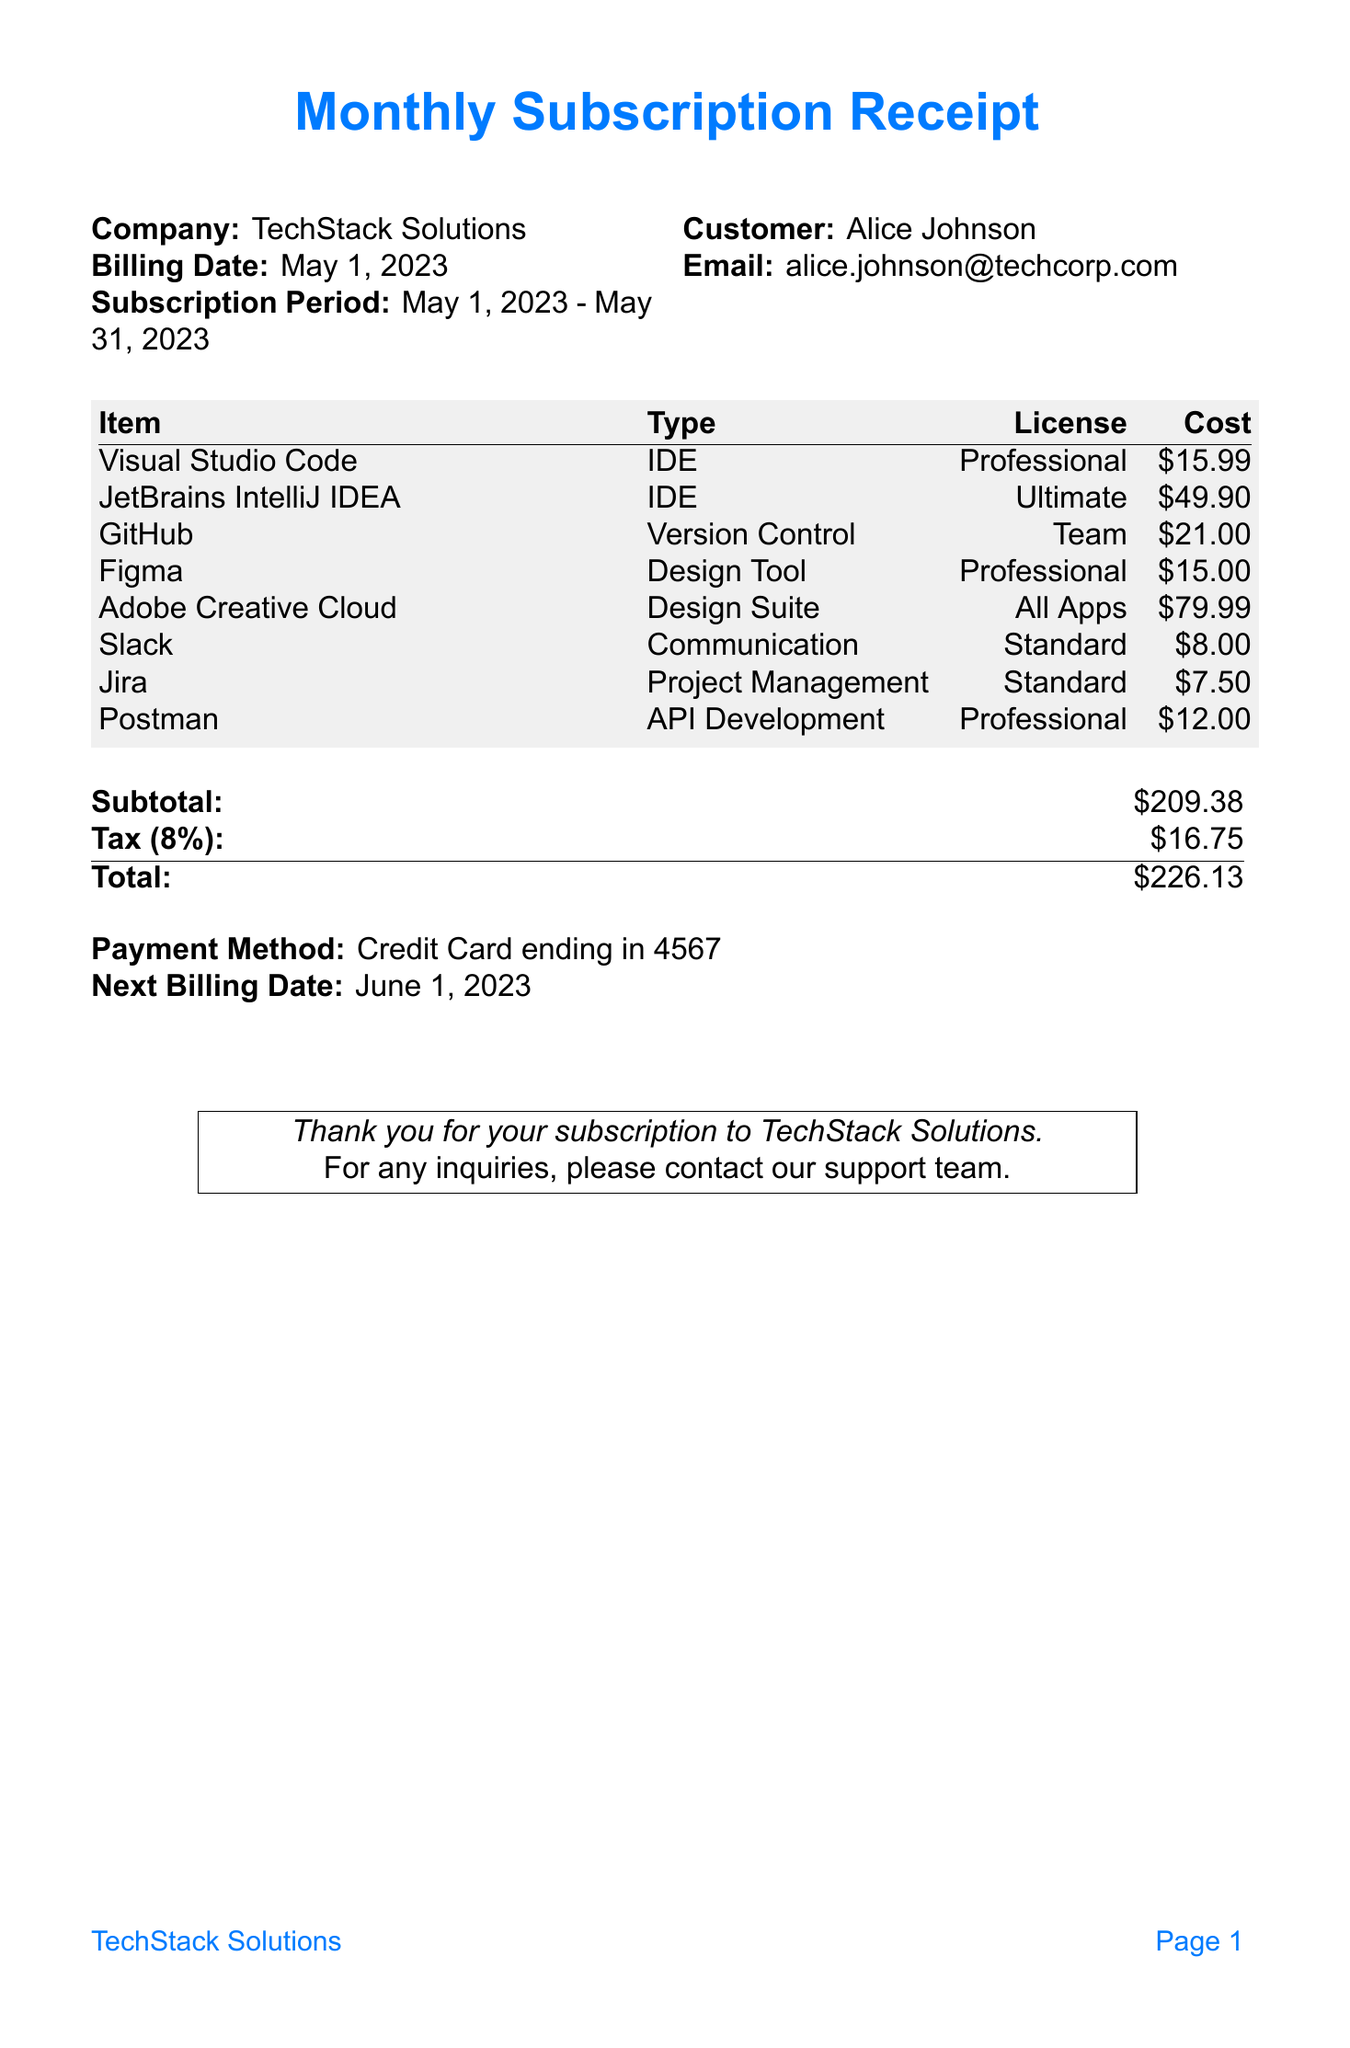what is the billing date? The billing date is specified in the document under the billing details.
Answer: May 1, 2023 who is the customer? The customer name is provided in the receipt, under the customer section.
Answer: Alice Johnson what is the total amount due? The total amount is calculated after subtotal and tax, provided at the end of the receipt.
Answer: 226.13 how many items are listed in the subscription? The number of subscription items can be counted from the itemized list provided.
Answer: 8 what is the license type for GitHub? The license type for GitHub can be found in the subscription items section.
Answer: Team what is the tax rate applied? The tax rate is displayed in the financial summary section of the document.
Answer: 8% what subscription tool has the highest cost? The tool with the highest cost is identified by comparing the costs listed in the document.
Answer: Adobe Creative Cloud what payment method was used? The payment method is mentioned in the financial summary section.
Answer: Credit Card ending in 4567 when is the next billing date? The next billing date is specifically noted in the document towards the end.
Answer: June 1, 2023 